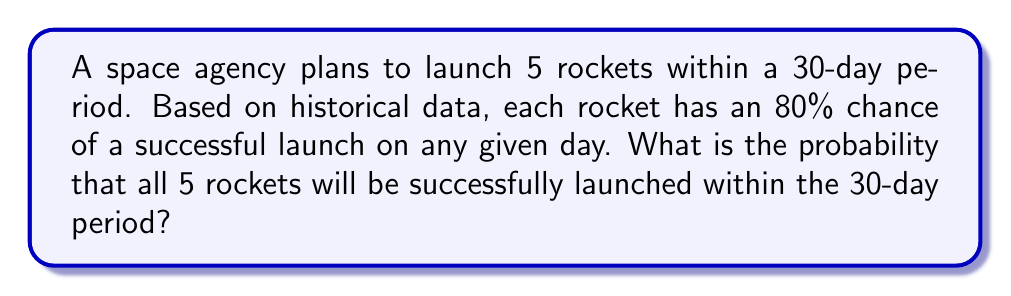Can you answer this question? Let's approach this step-by-step:

1) First, we need to calculate the probability of a successful launch for each rocket within the 30-day period.

2) The probability of a rocket not launching successfully on a given day is $1 - 0.80 = 0.20$ or 20%.

3) The probability of a rocket not launching successfully for all 30 days is:
   $$(0.20)^{30} = 1.0737 \times 10^{-21}$$

4) Therefore, the probability of a successful launch for each rocket within the 30-day period is:
   $$1 - (0.20)^{30} = 0.999999999999999999989263$$

5) Now, we need all 5 rockets to launch successfully. Since each launch is independent, we multiply the individual probabilities:
   $$(0.999999999999999999989263)^5 = 0.999999999999999999946315$$

6) To convert this to a percentage, we multiply by 100:
   $$0.999999999999999999946315 \times 100 \approx 99.9999999999999999995\%$$

This extremely high probability is due to the long time frame (30 days) compared to the high daily success rate (80%).
Answer: $\approx 99.9999999999999999995\%$ 